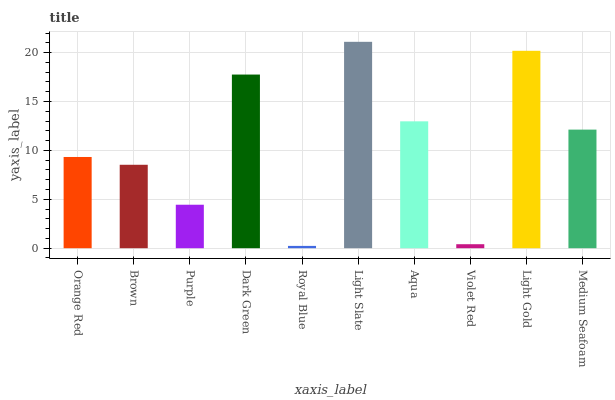Is Royal Blue the minimum?
Answer yes or no. Yes. Is Light Slate the maximum?
Answer yes or no. Yes. Is Brown the minimum?
Answer yes or no. No. Is Brown the maximum?
Answer yes or no. No. Is Orange Red greater than Brown?
Answer yes or no. Yes. Is Brown less than Orange Red?
Answer yes or no. Yes. Is Brown greater than Orange Red?
Answer yes or no. No. Is Orange Red less than Brown?
Answer yes or no. No. Is Medium Seafoam the high median?
Answer yes or no. Yes. Is Orange Red the low median?
Answer yes or no. Yes. Is Purple the high median?
Answer yes or no. No. Is Purple the low median?
Answer yes or no. No. 